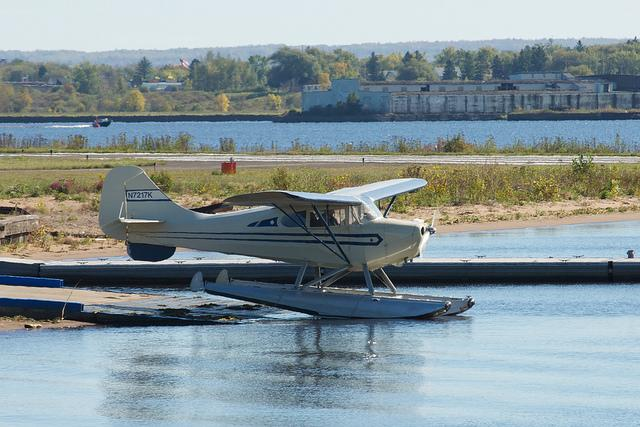What class of aircraft is seen here?

Choices:
A) helicopter
B) amphibious
C) cargo plane
D) fighter jet amphibious 